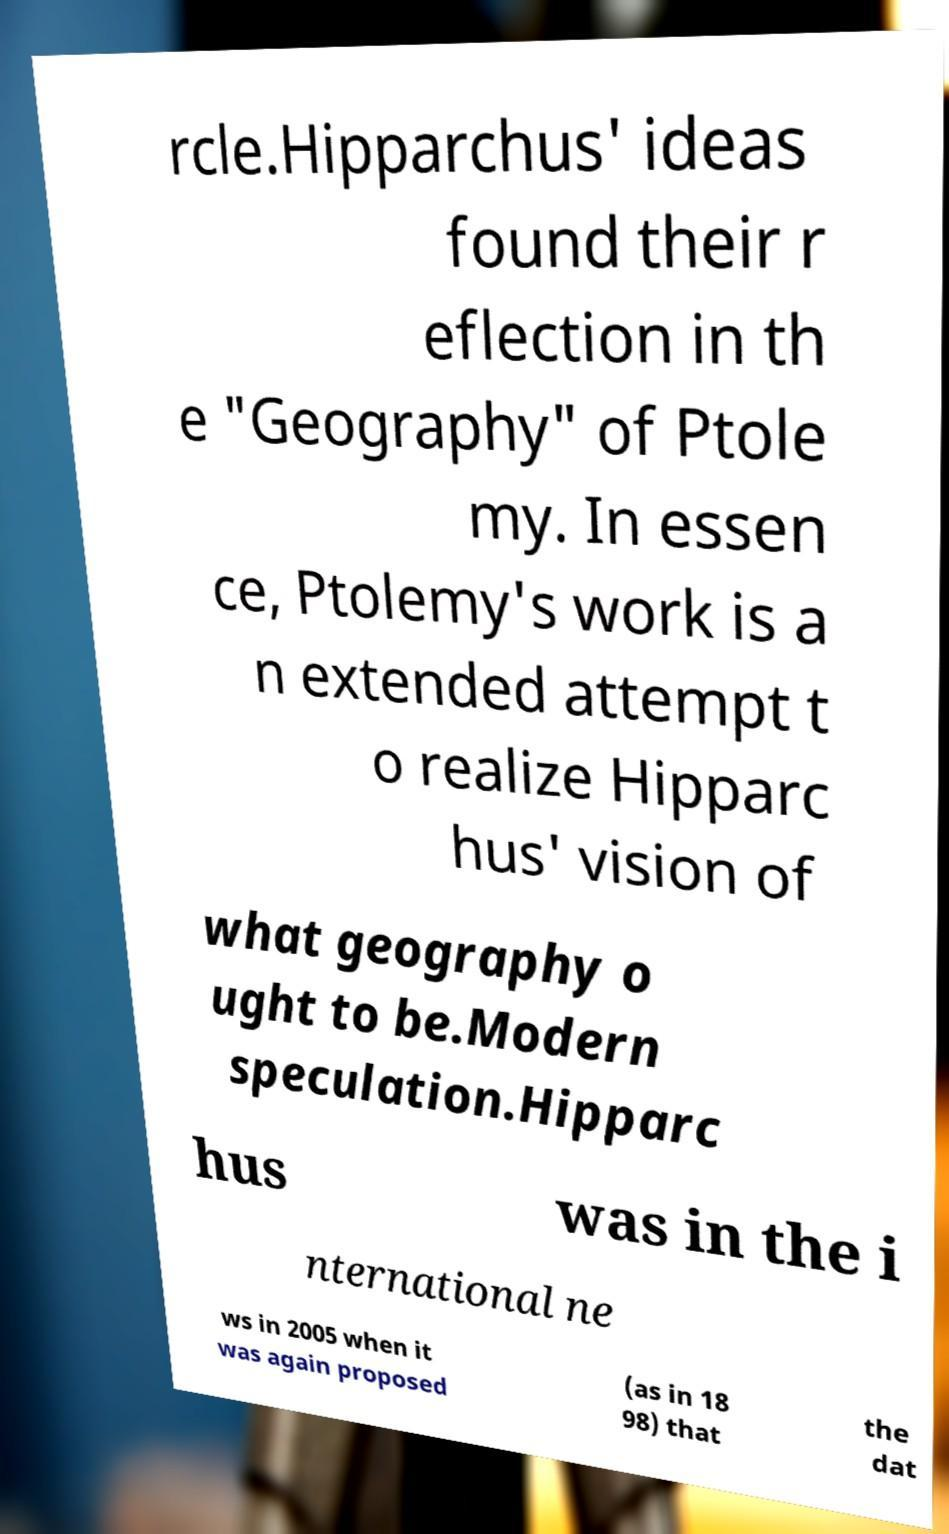Can you accurately transcribe the text from the provided image for me? rcle.Hipparchus' ideas found their r eflection in th e "Geography" of Ptole my. In essen ce, Ptolemy's work is a n extended attempt t o realize Hipparc hus' vision of what geography o ught to be.Modern speculation.Hipparc hus was in the i nternational ne ws in 2005 when it was again proposed (as in 18 98) that the dat 